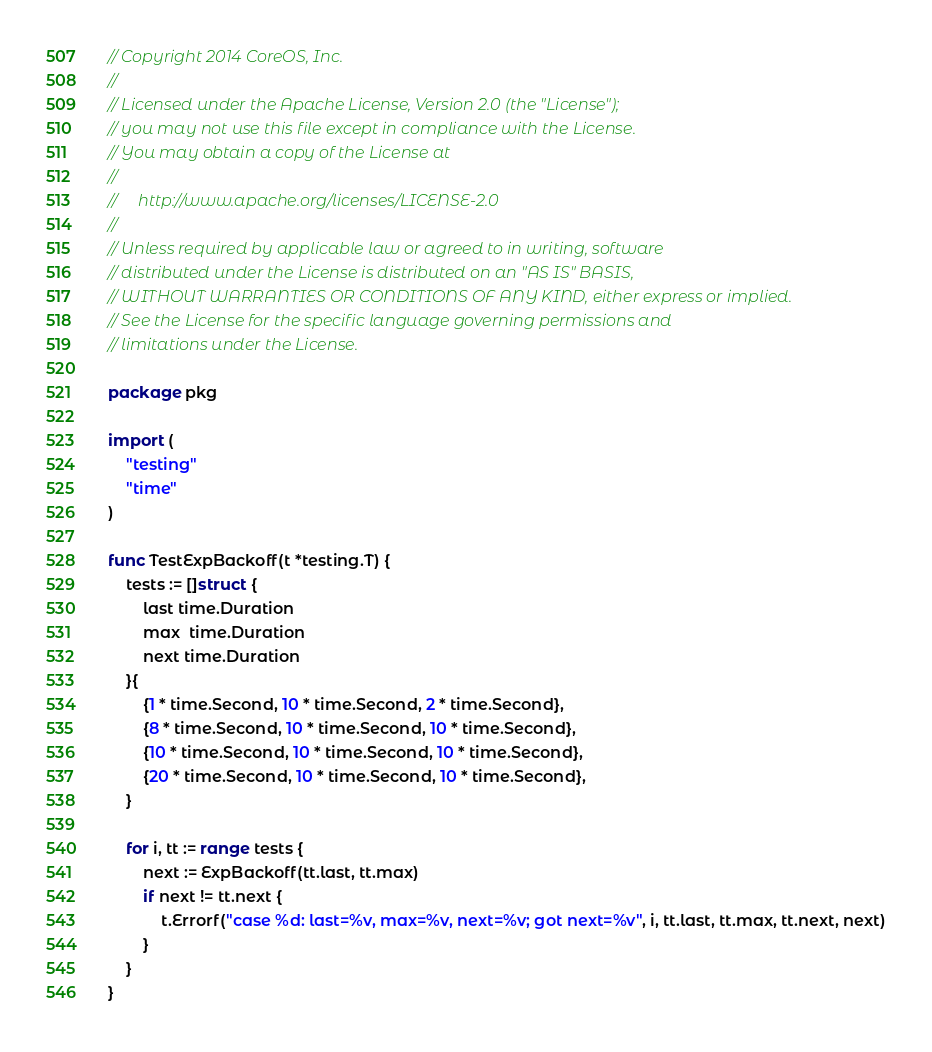<code> <loc_0><loc_0><loc_500><loc_500><_Go_>// Copyright 2014 CoreOS, Inc.
//
// Licensed under the Apache License, Version 2.0 (the "License");
// you may not use this file except in compliance with the License.
// You may obtain a copy of the License at
//
//     http://www.apache.org/licenses/LICENSE-2.0
//
// Unless required by applicable law or agreed to in writing, software
// distributed under the License is distributed on an "AS IS" BASIS,
// WITHOUT WARRANTIES OR CONDITIONS OF ANY KIND, either express or implied.
// See the License for the specific language governing permissions and
// limitations under the License.

package pkg

import (
	"testing"
	"time"
)

func TestExpBackoff(t *testing.T) {
	tests := []struct {
		last time.Duration
		max  time.Duration
		next time.Duration
	}{
		{1 * time.Second, 10 * time.Second, 2 * time.Second},
		{8 * time.Second, 10 * time.Second, 10 * time.Second},
		{10 * time.Second, 10 * time.Second, 10 * time.Second},
		{20 * time.Second, 10 * time.Second, 10 * time.Second},
	}

	for i, tt := range tests {
		next := ExpBackoff(tt.last, tt.max)
		if next != tt.next {
			t.Errorf("case %d: last=%v, max=%v, next=%v; got next=%v", i, tt.last, tt.max, tt.next, next)
		}
	}
}
</code> 